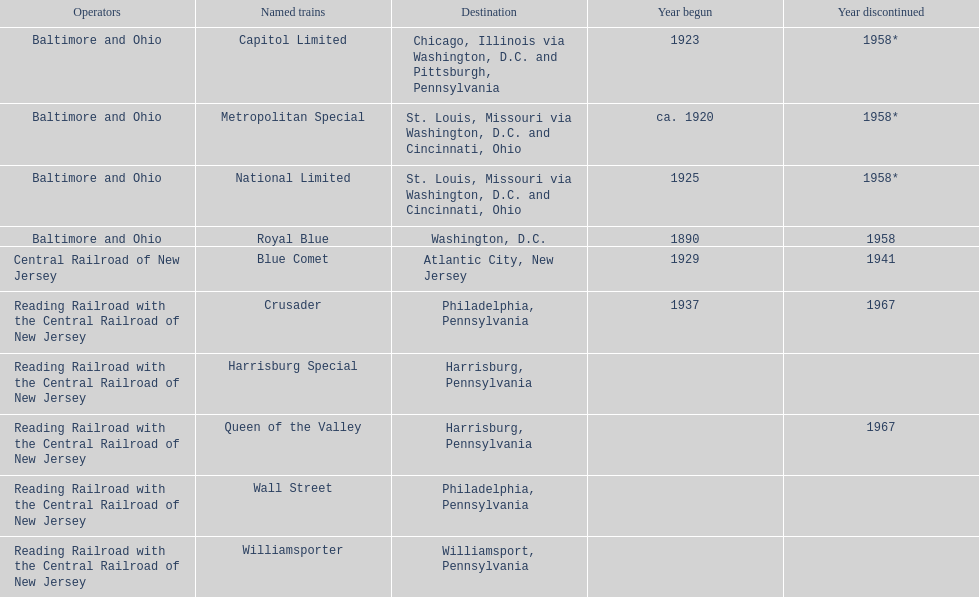Which train ran for the longest time? Royal Blue. 